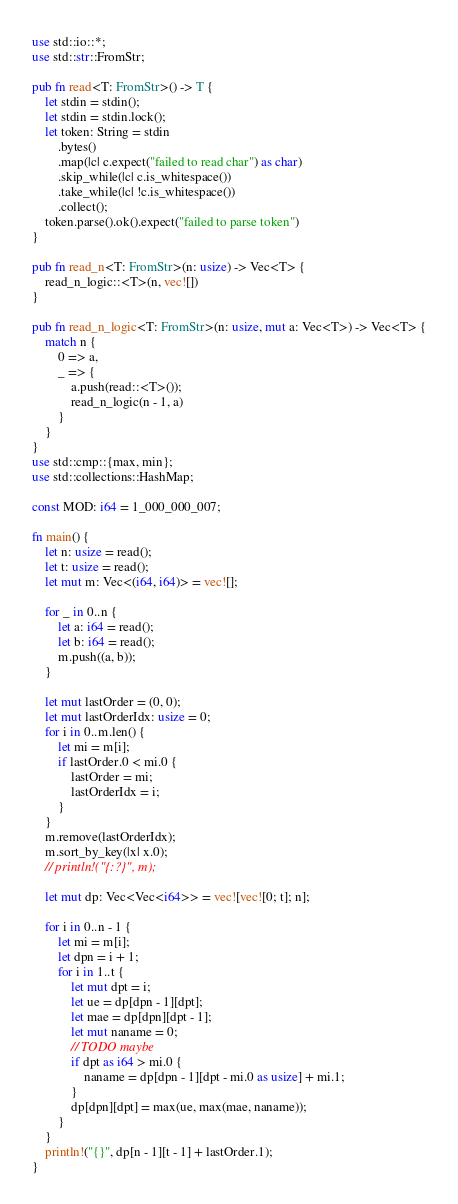<code> <loc_0><loc_0><loc_500><loc_500><_Rust_>use std::io::*;
use std::str::FromStr;

pub fn read<T: FromStr>() -> T {
    let stdin = stdin();
    let stdin = stdin.lock();
    let token: String = stdin
        .bytes()
        .map(|c| c.expect("failed to read char") as char)
        .skip_while(|c| c.is_whitespace())
        .take_while(|c| !c.is_whitespace())
        .collect();
    token.parse().ok().expect("failed to parse token")
}

pub fn read_n<T: FromStr>(n: usize) -> Vec<T> {
    read_n_logic::<T>(n, vec![])
}

pub fn read_n_logic<T: FromStr>(n: usize, mut a: Vec<T>) -> Vec<T> {
    match n {
        0 => a,
        _ => {
            a.push(read::<T>());
            read_n_logic(n - 1, a)
        }
    }
}
use std::cmp::{max, min};
use std::collections::HashMap;

const MOD: i64 = 1_000_000_007;

fn main() {
    let n: usize = read();
    let t: usize = read();
    let mut m: Vec<(i64, i64)> = vec![];

    for _ in 0..n {
        let a: i64 = read();
        let b: i64 = read();
        m.push((a, b));
    }

    let mut lastOrder = (0, 0);
    let mut lastOrderIdx: usize = 0;
    for i in 0..m.len() {
        let mi = m[i];
        if lastOrder.0 < mi.0 {
            lastOrder = mi;
            lastOrderIdx = i;
        }
    }
    m.remove(lastOrderIdx);
    m.sort_by_key(|x| x.0);
    // println!("{:?}", m);

    let mut dp: Vec<Vec<i64>> = vec![vec![0; t]; n];

    for i in 0..n - 1 {
        let mi = m[i];
        let dpn = i + 1;
        for i in 1..t {
            let mut dpt = i;
            let ue = dp[dpn - 1][dpt];
            let mae = dp[dpn][dpt - 1];
            let mut naname = 0;
            // TODO maybe
            if dpt as i64 > mi.0 {
                naname = dp[dpn - 1][dpt - mi.0 as usize] + mi.1;
            }
            dp[dpn][dpt] = max(ue, max(mae, naname));
        }
    }
    println!("{}", dp[n - 1][t - 1] + lastOrder.1);
}
</code> 